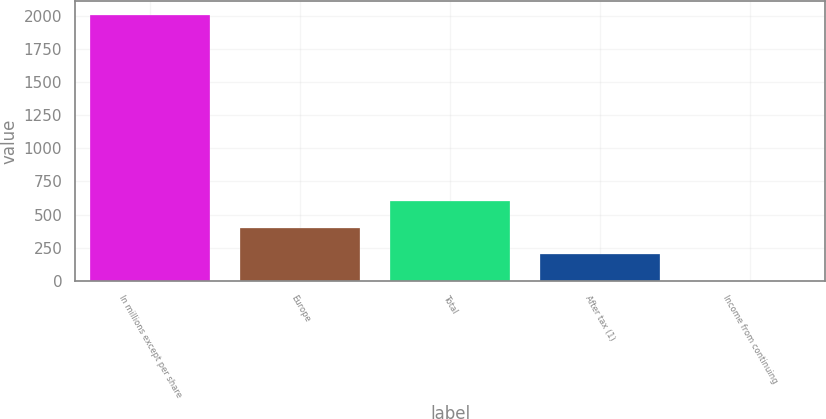Convert chart to OTSL. <chart><loc_0><loc_0><loc_500><loc_500><bar_chart><fcel>In millions except per share<fcel>Europe<fcel>Total<fcel>After tax (1)<fcel>Income from continuing<nl><fcel>2008<fcel>401.61<fcel>602.41<fcel>200.81<fcel>0.01<nl></chart> 